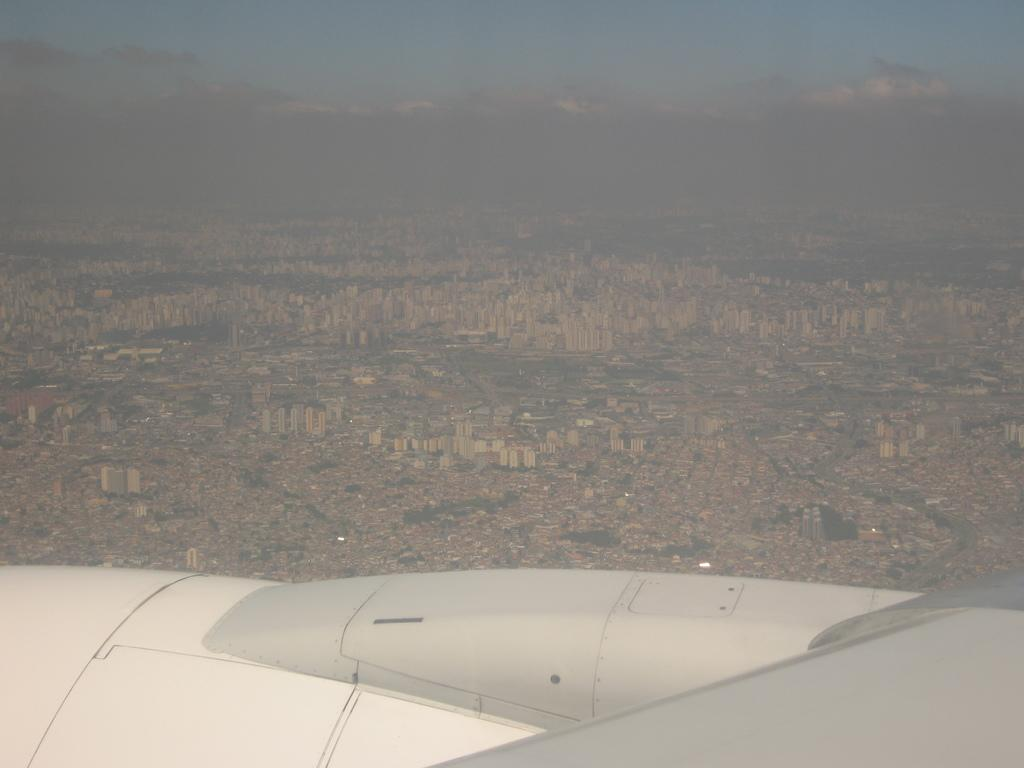What is the main subject of the image? The main subject of the image is a part of an airplane. What can be seen in the background of the image? There are buildings and a cloudy sky in the background of the image. What type of work is the carpenter doing in the image? There is no carpenter present in the image. Is the secretary in the image currently taking a nap? There is no secretary present in the image, so it cannot be determined if they are sleeping or not. 